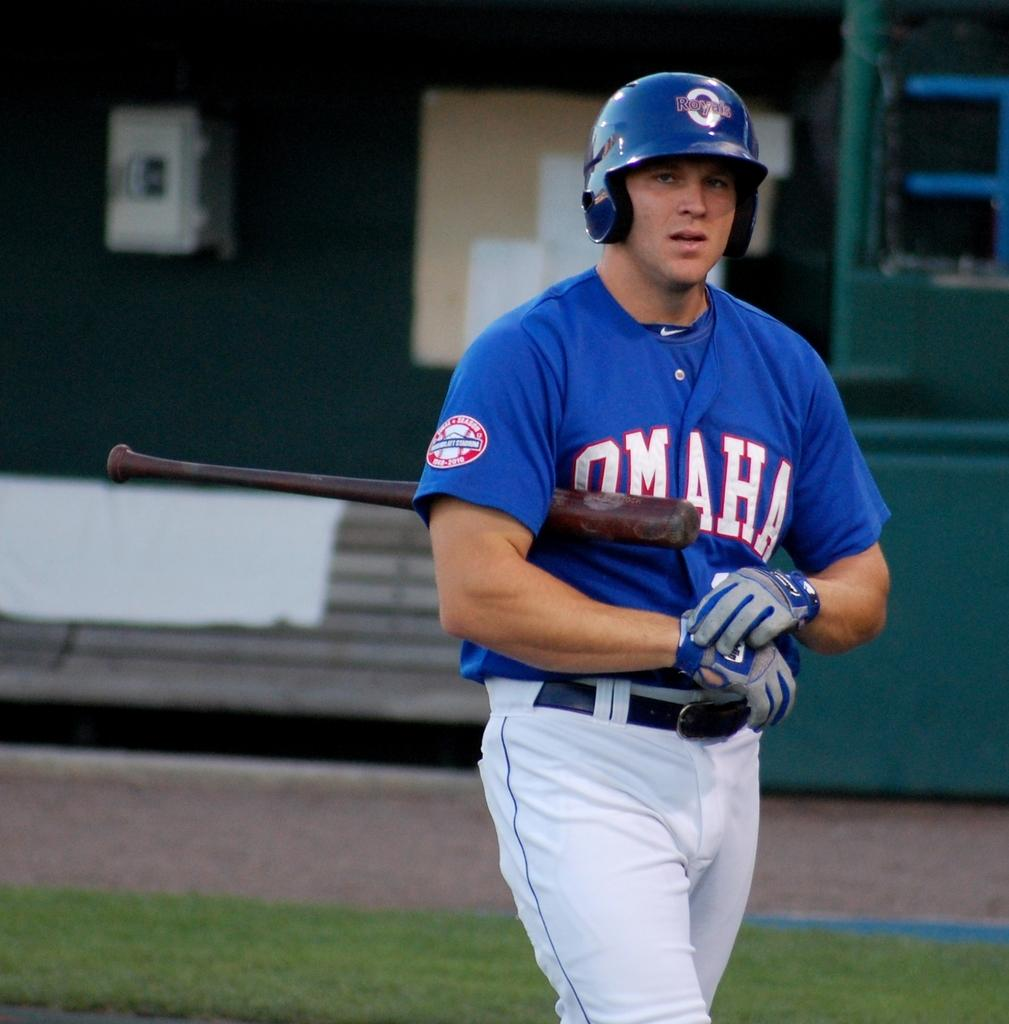<image>
Describe the image concisely. A man who plays for Omaha is adjusting his batting glove. 